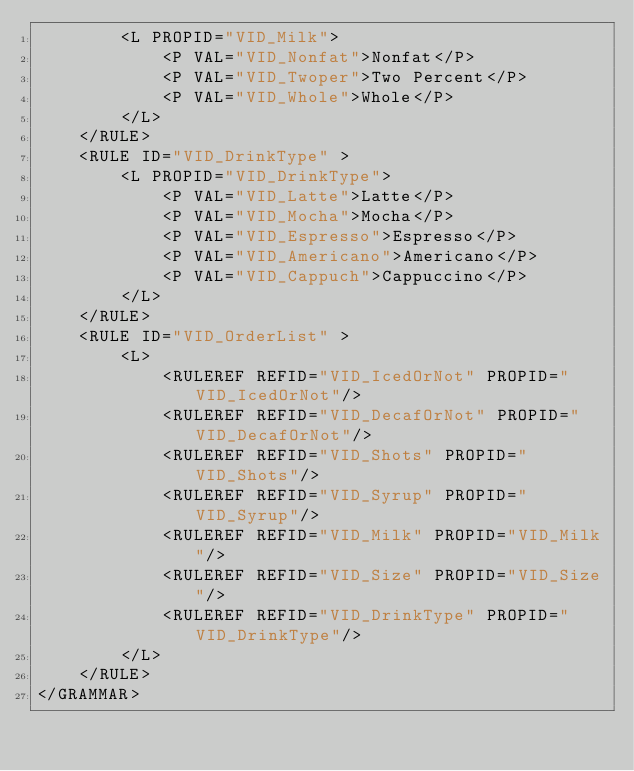<code> <loc_0><loc_0><loc_500><loc_500><_XML_>        <L PROPID="VID_Milk">
            <P VAL="VID_Nonfat">Nonfat</P>
            <P VAL="VID_Twoper">Two Percent</P>
            <P VAL="VID_Whole">Whole</P>
        </L>
    </RULE>
    <RULE ID="VID_DrinkType" >
        <L PROPID="VID_DrinkType">
            <P VAL="VID_Latte">Latte</P>
            <P VAL="VID_Mocha">Mocha</P>
            <P VAL="VID_Espresso">Espresso</P>
            <P VAL="VID_Americano">Americano</P>
            <P VAL="VID_Cappuch">Cappuccino</P>
        </L>
    </RULE>
    <RULE ID="VID_OrderList" >
        <L>
            <RULEREF REFID="VID_IcedOrNot" PROPID="VID_IcedOrNot"/> 
            <RULEREF REFID="VID_DecafOrNot" PROPID="VID_DecafOrNot"/> 
            <RULEREF REFID="VID_Shots" PROPID="VID_Shots"/> 
            <RULEREF REFID="VID_Syrup" PROPID="VID_Syrup"/> 
            <RULEREF REFID="VID_Milk" PROPID="VID_Milk"/> 
            <RULEREF REFID="VID_Size" PROPID="VID_Size"/> 
            <RULEREF REFID="VID_DrinkType" PROPID="VID_DrinkType"/> 
        </L>
    </RULE>
</GRAMMAR>
</code> 